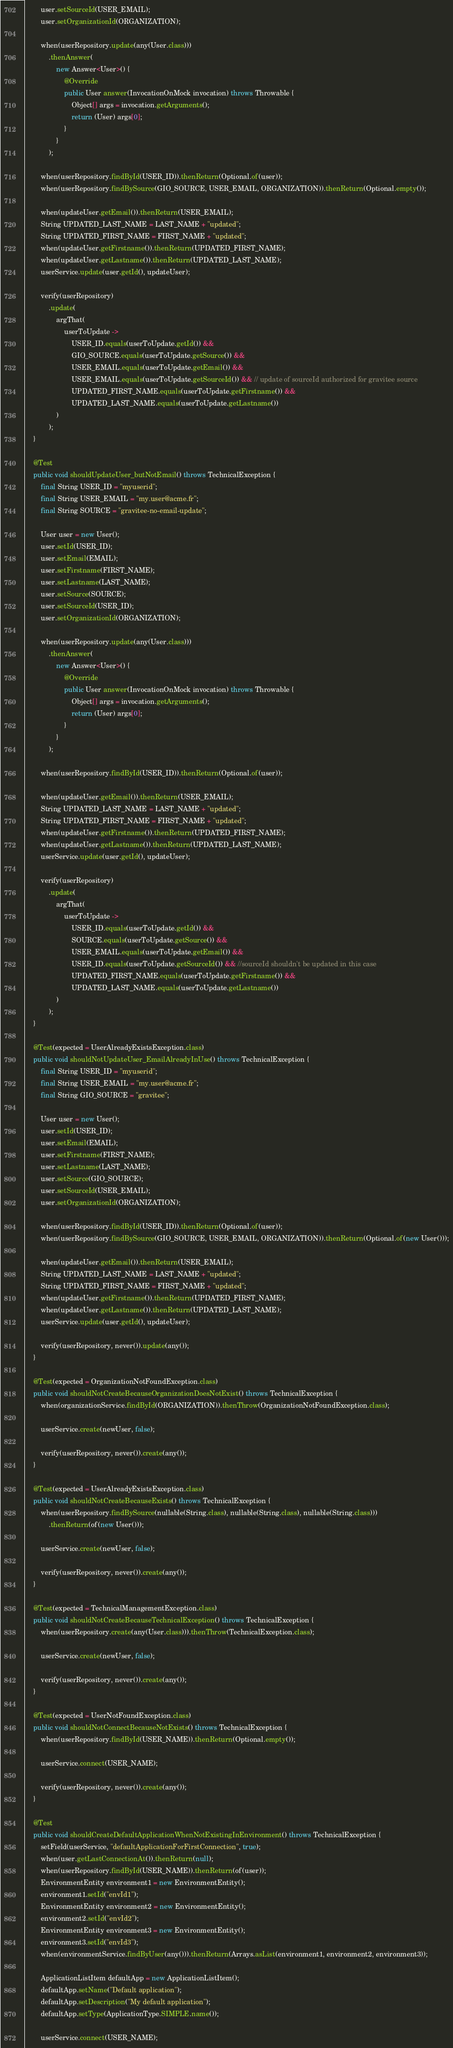<code> <loc_0><loc_0><loc_500><loc_500><_Java_>        user.setSourceId(USER_EMAIL);
        user.setOrganizationId(ORGANIZATION);

        when(userRepository.update(any(User.class)))
            .thenAnswer(
                new Answer<User>() {
                    @Override
                    public User answer(InvocationOnMock invocation) throws Throwable {
                        Object[] args = invocation.getArguments();
                        return (User) args[0];
                    }
                }
            );

        when(userRepository.findById(USER_ID)).thenReturn(Optional.of(user));
        when(userRepository.findBySource(GIO_SOURCE, USER_EMAIL, ORGANIZATION)).thenReturn(Optional.empty());

        when(updateUser.getEmail()).thenReturn(USER_EMAIL);
        String UPDATED_LAST_NAME = LAST_NAME + "updated";
        String UPDATED_FIRST_NAME = FIRST_NAME + "updated";
        when(updateUser.getFirstname()).thenReturn(UPDATED_FIRST_NAME);
        when(updateUser.getLastname()).thenReturn(UPDATED_LAST_NAME);
        userService.update(user.getId(), updateUser);

        verify(userRepository)
            .update(
                argThat(
                    userToUpdate ->
                        USER_ID.equals(userToUpdate.getId()) &&
                        GIO_SOURCE.equals(userToUpdate.getSource()) &&
                        USER_EMAIL.equals(userToUpdate.getEmail()) &&
                        USER_EMAIL.equals(userToUpdate.getSourceId()) && // update of sourceId authorized for gravitee source
                        UPDATED_FIRST_NAME.equals(userToUpdate.getFirstname()) &&
                        UPDATED_LAST_NAME.equals(userToUpdate.getLastname())
                )
            );
    }

    @Test
    public void shouldUpdateUser_butNotEmail() throws TechnicalException {
        final String USER_ID = "myuserid";
        final String USER_EMAIL = "my.user@acme.fr";
        final String SOURCE = "gravitee-no-email-update";

        User user = new User();
        user.setId(USER_ID);
        user.setEmail(EMAIL);
        user.setFirstname(FIRST_NAME);
        user.setLastname(LAST_NAME);
        user.setSource(SOURCE);
        user.setSourceId(USER_ID);
        user.setOrganizationId(ORGANIZATION);

        when(userRepository.update(any(User.class)))
            .thenAnswer(
                new Answer<User>() {
                    @Override
                    public User answer(InvocationOnMock invocation) throws Throwable {
                        Object[] args = invocation.getArguments();
                        return (User) args[0];
                    }
                }
            );

        when(userRepository.findById(USER_ID)).thenReturn(Optional.of(user));

        when(updateUser.getEmail()).thenReturn(USER_EMAIL);
        String UPDATED_LAST_NAME = LAST_NAME + "updated";
        String UPDATED_FIRST_NAME = FIRST_NAME + "updated";
        when(updateUser.getFirstname()).thenReturn(UPDATED_FIRST_NAME);
        when(updateUser.getLastname()).thenReturn(UPDATED_LAST_NAME);
        userService.update(user.getId(), updateUser);

        verify(userRepository)
            .update(
                argThat(
                    userToUpdate ->
                        USER_ID.equals(userToUpdate.getId()) &&
                        SOURCE.equals(userToUpdate.getSource()) &&
                        USER_EMAIL.equals(userToUpdate.getEmail()) &&
                        USER_ID.equals(userToUpdate.getSourceId()) && //sourceId shouldn't be updated in this case
                        UPDATED_FIRST_NAME.equals(userToUpdate.getFirstname()) &&
                        UPDATED_LAST_NAME.equals(userToUpdate.getLastname())
                )
            );
    }

    @Test(expected = UserAlreadyExistsException.class)
    public void shouldNotUpdateUser_EmailAlreadyInUse() throws TechnicalException {
        final String USER_ID = "myuserid";
        final String USER_EMAIL = "my.user@acme.fr";
        final String GIO_SOURCE = "gravitee";

        User user = new User();
        user.setId(USER_ID);
        user.setEmail(EMAIL);
        user.setFirstname(FIRST_NAME);
        user.setLastname(LAST_NAME);
        user.setSource(GIO_SOURCE);
        user.setSourceId(USER_EMAIL);
        user.setOrganizationId(ORGANIZATION);

        when(userRepository.findById(USER_ID)).thenReturn(Optional.of(user));
        when(userRepository.findBySource(GIO_SOURCE, USER_EMAIL, ORGANIZATION)).thenReturn(Optional.of(new User()));

        when(updateUser.getEmail()).thenReturn(USER_EMAIL);
        String UPDATED_LAST_NAME = LAST_NAME + "updated";
        String UPDATED_FIRST_NAME = FIRST_NAME + "updated";
        when(updateUser.getFirstname()).thenReturn(UPDATED_FIRST_NAME);
        when(updateUser.getLastname()).thenReturn(UPDATED_LAST_NAME);
        userService.update(user.getId(), updateUser);

        verify(userRepository, never()).update(any());
    }

    @Test(expected = OrganizationNotFoundException.class)
    public void shouldNotCreateBecauseOrganizationDoesNotExist() throws TechnicalException {
        when(organizationService.findById(ORGANIZATION)).thenThrow(OrganizationNotFoundException.class);

        userService.create(newUser, false);

        verify(userRepository, never()).create(any());
    }

    @Test(expected = UserAlreadyExistsException.class)
    public void shouldNotCreateBecauseExists() throws TechnicalException {
        when(userRepository.findBySource(nullable(String.class), nullable(String.class), nullable(String.class)))
            .thenReturn(of(new User()));

        userService.create(newUser, false);

        verify(userRepository, never()).create(any());
    }

    @Test(expected = TechnicalManagementException.class)
    public void shouldNotCreateBecauseTechnicalException() throws TechnicalException {
        when(userRepository.create(any(User.class))).thenThrow(TechnicalException.class);

        userService.create(newUser, false);

        verify(userRepository, never()).create(any());
    }

    @Test(expected = UserNotFoundException.class)
    public void shouldNotConnectBecauseNotExists() throws TechnicalException {
        when(userRepository.findById(USER_NAME)).thenReturn(Optional.empty());

        userService.connect(USER_NAME);

        verify(userRepository, never()).create(any());
    }

    @Test
    public void shouldCreateDefaultApplicationWhenNotExistingInEnvironment() throws TechnicalException {
        setField(userService, "defaultApplicationForFirstConnection", true);
        when(user.getLastConnectionAt()).thenReturn(null);
        when(userRepository.findById(USER_NAME)).thenReturn(of(user));
        EnvironmentEntity environment1 = new EnvironmentEntity();
        environment1.setId("envId1");
        EnvironmentEntity environment2 = new EnvironmentEntity();
        environment2.setId("envId2");
        EnvironmentEntity environment3 = new EnvironmentEntity();
        environment3.setId("envId3");
        when(environmentService.findByUser(any())).thenReturn(Arrays.asList(environment1, environment2, environment3));

        ApplicationListItem defaultApp = new ApplicationListItem();
        defaultApp.setName("Default application");
        defaultApp.setDescription("My default application");
        defaultApp.setType(ApplicationType.SIMPLE.name());

        userService.connect(USER_NAME);
</code> 